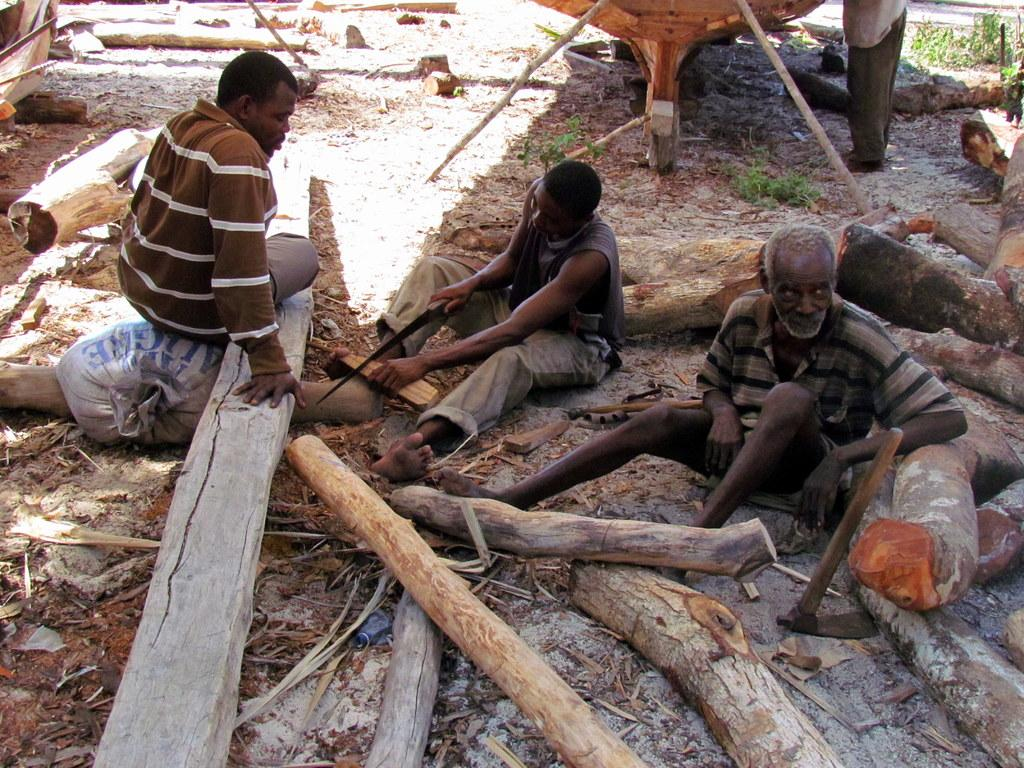How many people are in the image? There are three people in the image. What are the people doing in the image? The people are sitting and cutting trees. What type of pies are being served at the camp in the image? There is no camp or pies present in the image; it features three people sitting and cutting trees. What is the condition of the neck of the person in the middle of the image? There is no information about the neck of any person in the image, as it only mentions that they are sitting and cutting trees. 